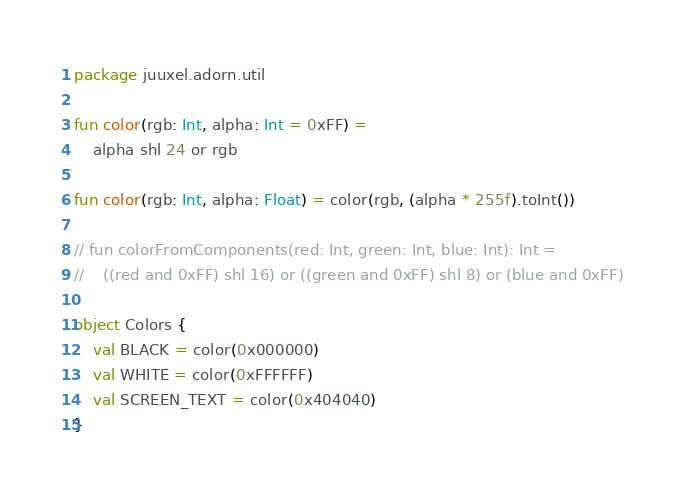<code> <loc_0><loc_0><loc_500><loc_500><_Kotlin_>package juuxel.adorn.util

fun color(rgb: Int, alpha: Int = 0xFF) =
    alpha shl 24 or rgb

fun color(rgb: Int, alpha: Float) = color(rgb, (alpha * 255f).toInt())

// fun colorFromComponents(red: Int, green: Int, blue: Int): Int =
//    ((red and 0xFF) shl 16) or ((green and 0xFF) shl 8) or (blue and 0xFF)

object Colors {
    val BLACK = color(0x000000)
    val WHITE = color(0xFFFFFF)
    val SCREEN_TEXT = color(0x404040)
}
</code> 